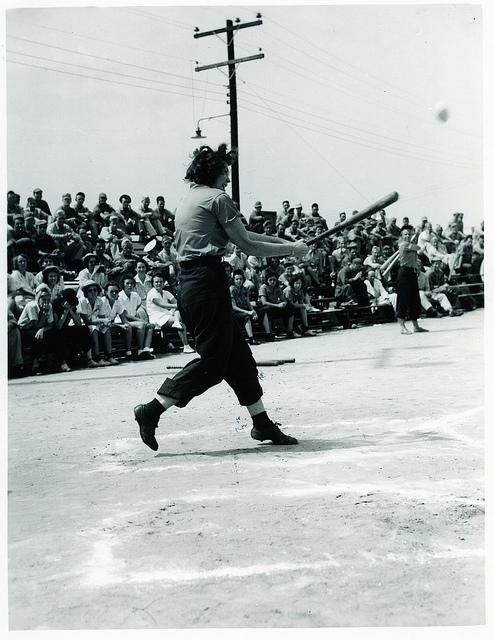What sport are these women most likely playing? baseball 